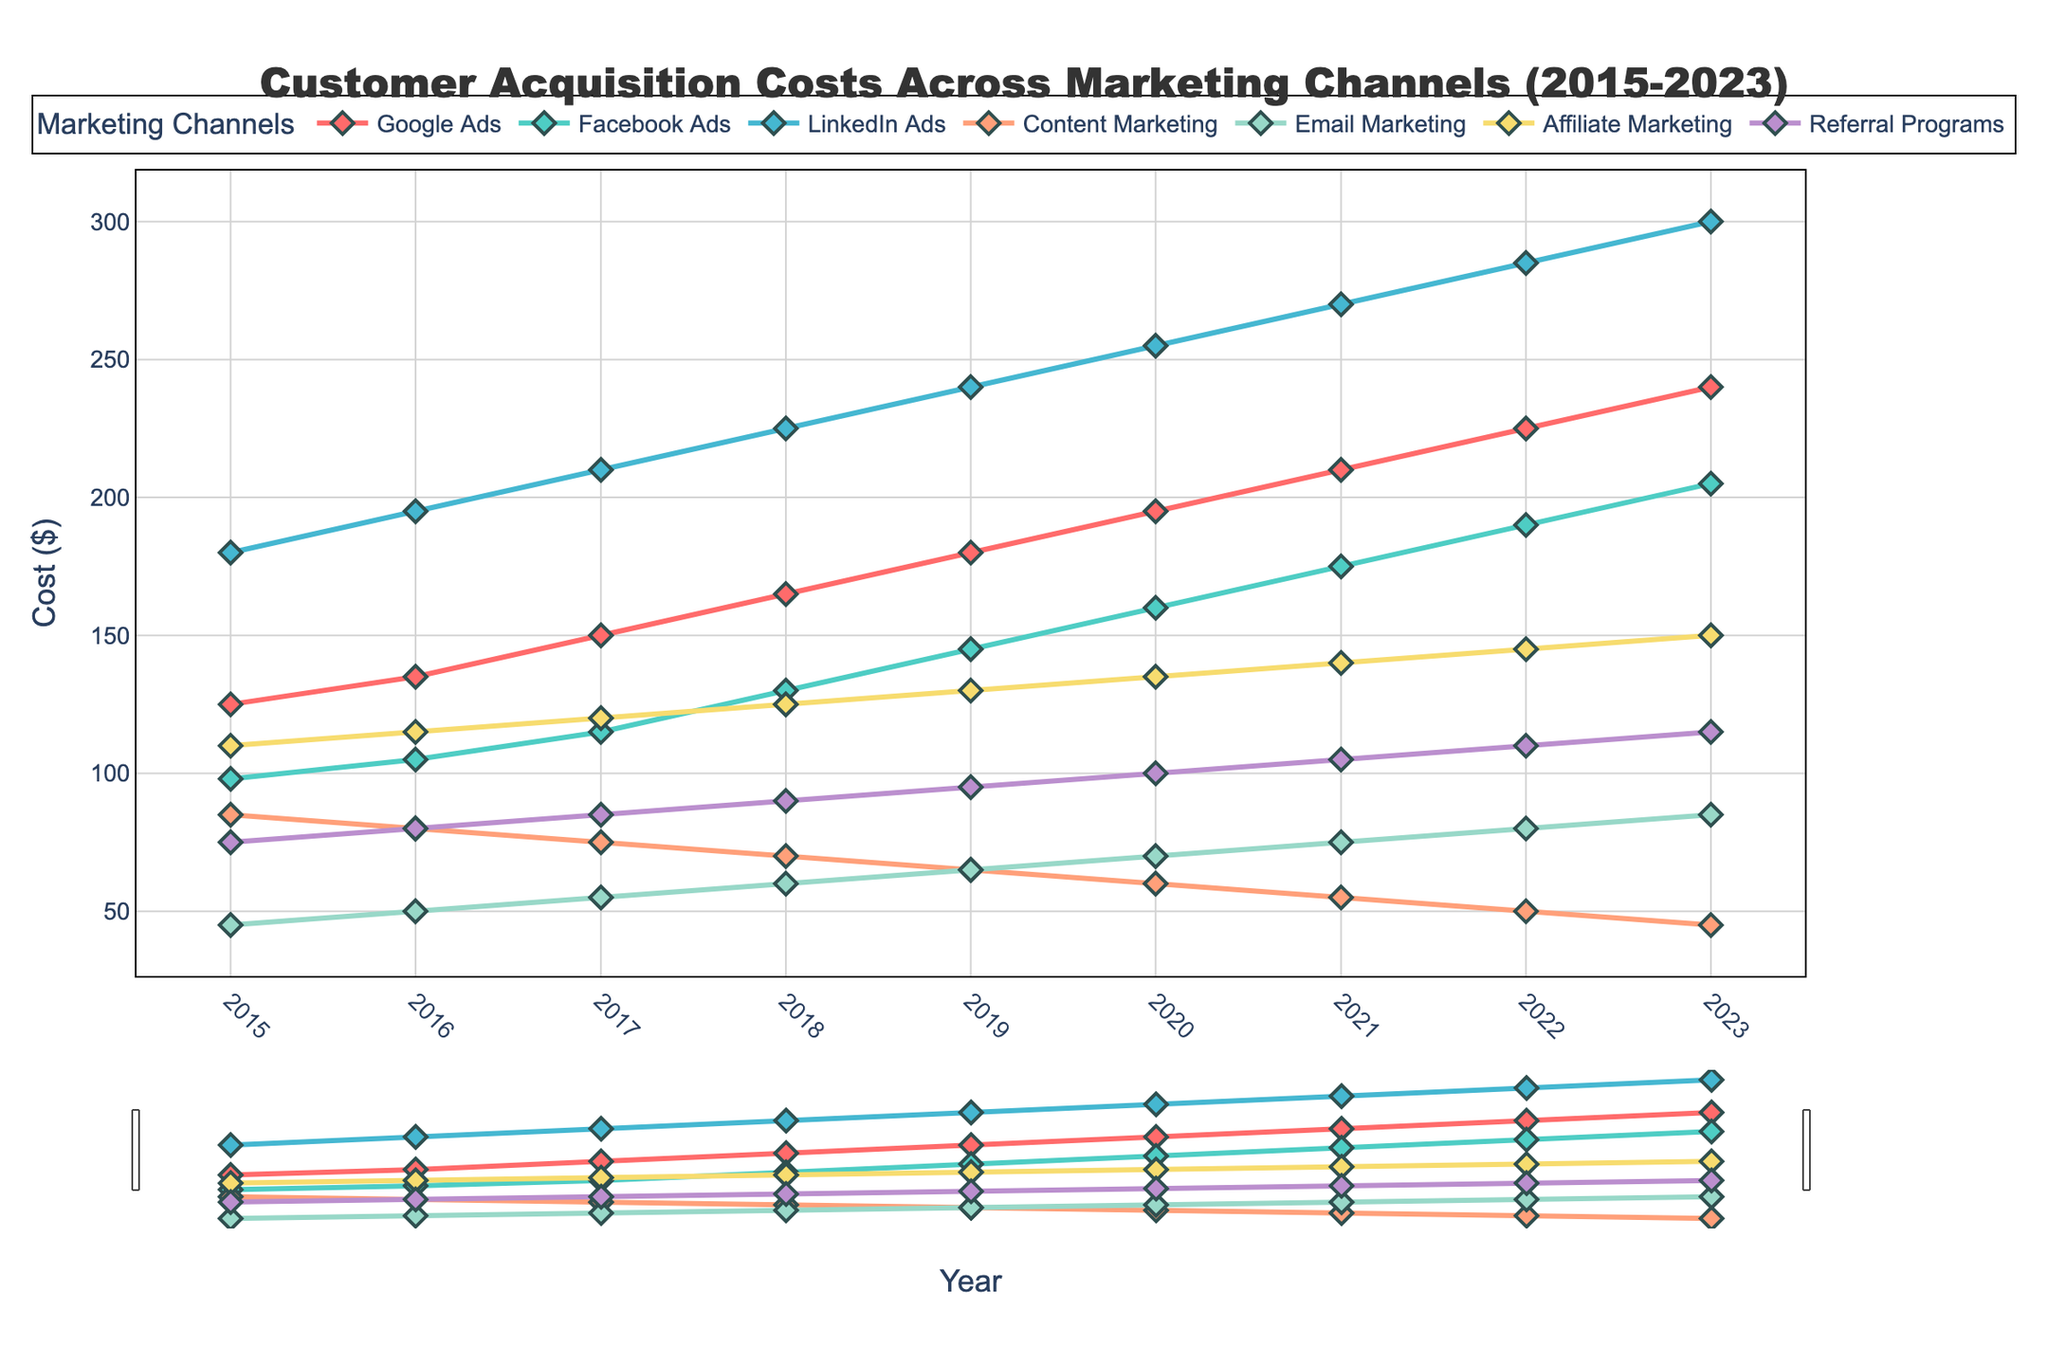What's the overall trend for Google Ads from 2015 to 2023? Google Ads shows a consistent increasing trend from 2015 to 2023, starting at $125 in 2015 and reaching $240 in 2023.
Answer: Increasing Which marketing channel had the highest cost in 2023? By observing the figure, LinkedIn Ads had the highest cost in 2023, reaching $300.
Answer: LinkedIn Ads How did the cost of Email Marketing change from 2015 to 2023? Email Marketing costs have consistently increased from $45 in 2015 to $85 in 2023.
Answer: Increased Which two marketing channels had the closest costs in 2015? In 2015, Content Marketing and Email Marketing had the closest costs at $85 and $45, respectively.
Answer: Content Marketing and Email Marketing By how much did the cost of Facebook Ads increase from 2015 to 2023? Facebook Ads increased from $98 in 2015 to $205 in 2023. The difference is 205 - 98 = 107.
Answer: 107 Which marketing channel had the smallest rate of increase from 2015 to 2023? By calculating the differences, Content Marketing had the smallest increase, going from $85 in 2015 to $45 in 2023, actually showing a decrease rather than an increase.
Answer: Content Marketing In which year did Affiliate Marketing cost surpass Content Marketing? Affiliate Marketing first surpassed Content Marketing in 2018, with values of $125 and $70, respectively.
Answer: 2018 What is the average cost of Referral Programs across all years? Sum the values for Referral Programs: 75+80+85+90+95+100+105+110+115 = 855. Divide by the number of years, 855/9 = 95.
Answer: 95 Between LinkedIn Ads and Google Ads, which channel had a higher increase from 2015 to 2023? Calculate the increases: LinkedIn Ads' increase is 300 - 180 = 120. Google Ads' increase is 240 - 125 = 115. LinkedIn Ads had a higher increase.
Answer: LinkedIn Ads Compare the cost of Google Ads in 2020 and Email Marketing in 2023. Which one is higher and by how much? Google Ads in 2020 was $195 and Email Marketing in 2023 was $85. The difference is 195 - 85 = 110, so Google Ads in 2020 was higher.
Answer: Google Ads by 110 